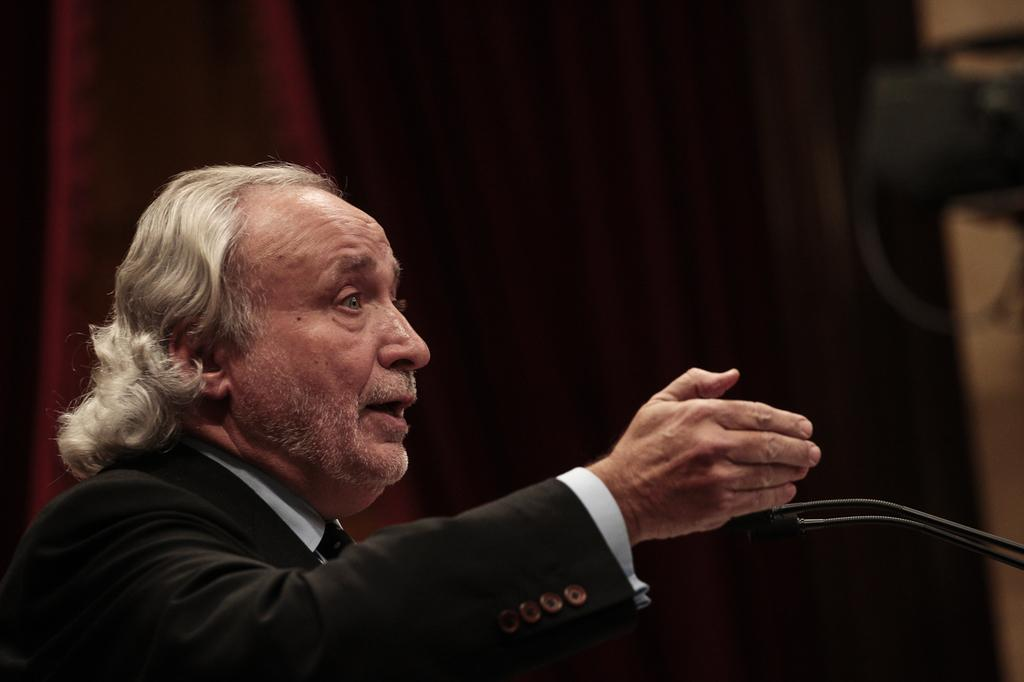Who is present in the image? There is a man in the image. What is the man wearing? The man is wearing a black suit. What objects can be seen in the image besides the man? There are microphones visible in the image. How would you describe the background of the image? The background of the image is blurred. What type of pets are visible in the image? There are no pets present in the image. What season is depicted in the image? The image does not depict a specific season, as there are no seasonal cues present. 